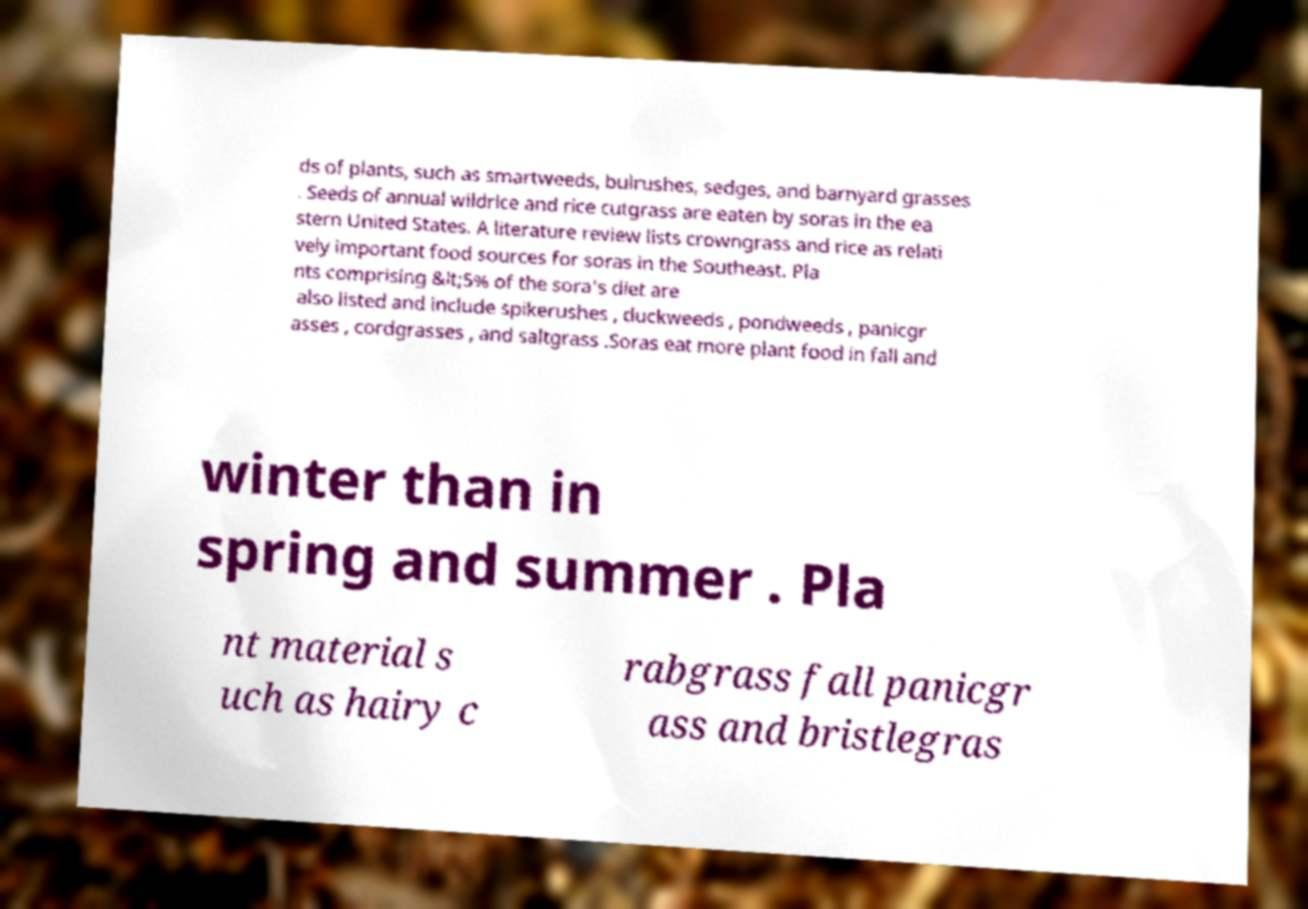For documentation purposes, I need the text within this image transcribed. Could you provide that? ds of plants, such as smartweeds, bulrushes, sedges, and barnyard grasses . Seeds of annual wildrice and rice cutgrass are eaten by soras in the ea stern United States. A literature review lists crowngrass and rice as relati vely important food sources for soras in the Southeast. Pla nts comprising &lt;5% of the sora's diet are also listed and include spikerushes , duckweeds , pondweeds , panicgr asses , cordgrasses , and saltgrass .Soras eat more plant food in fall and winter than in spring and summer . Pla nt material s uch as hairy c rabgrass fall panicgr ass and bristlegras 